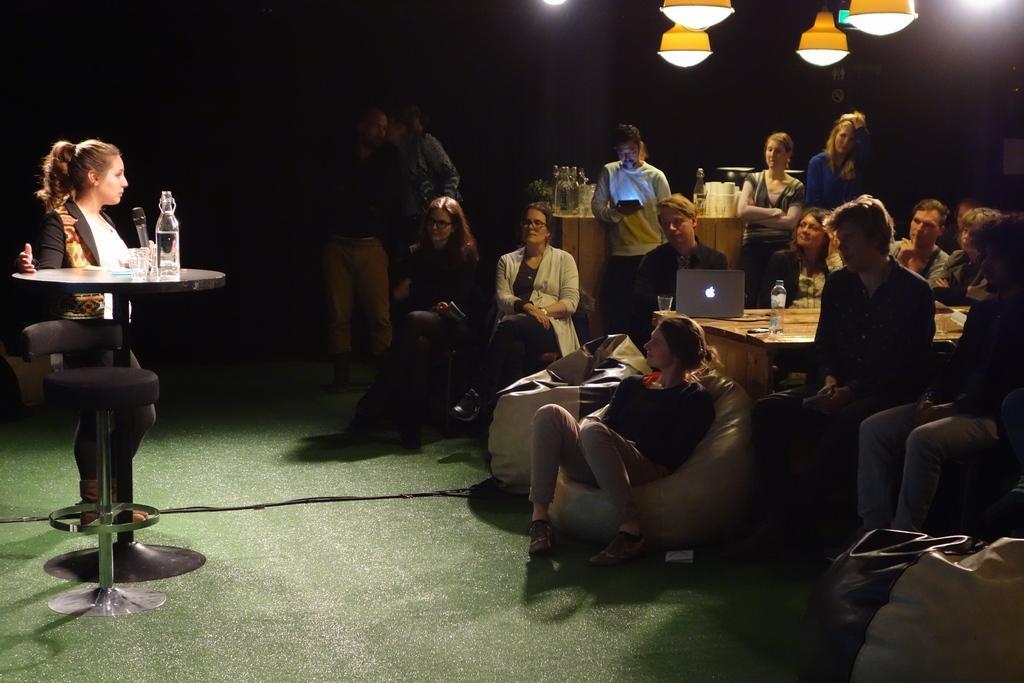Could you give a brief overview of what you see in this image? In this image I can see the group of people sitting and some people are standing. In front of them there is a table. On the table there is a laptop and the bottles. One person is holding the mic. 